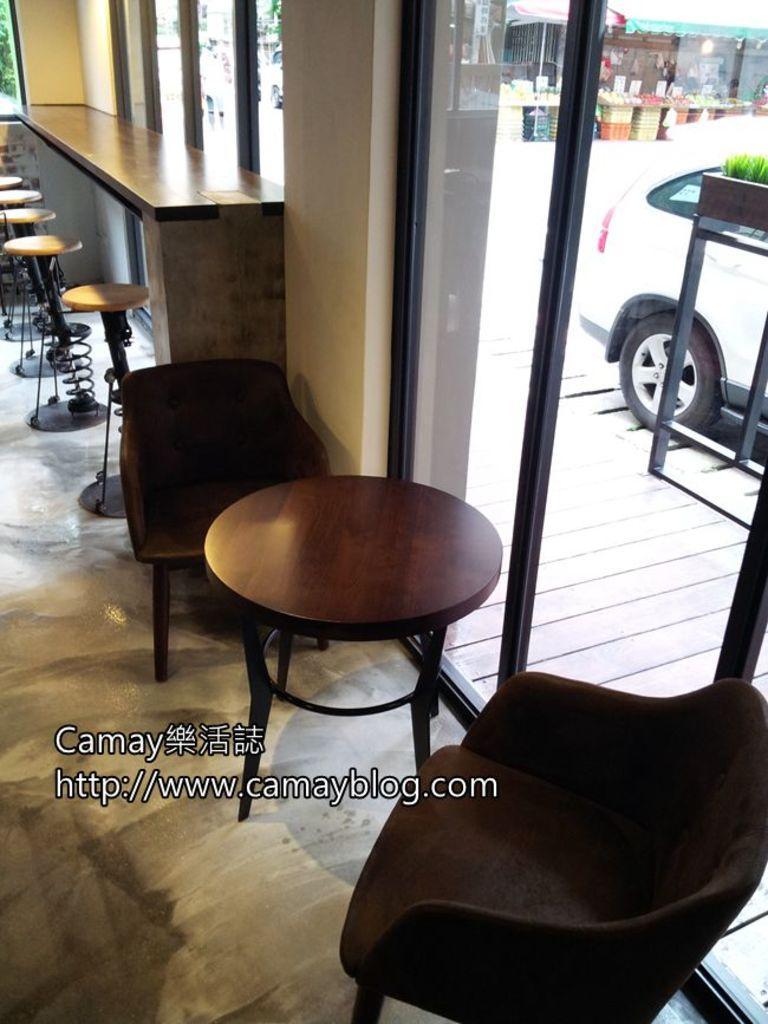Can you describe this image briefly? In this image, we can see few stools, chairs, table. At the bottom, there is a floor. Background, we can see glass doors. Through the glass, we can see the outside view. Here we can see few vehicles, some stalls, house. Here we can see a plant with pot. At the bottom, we can see a watermark in the image. 